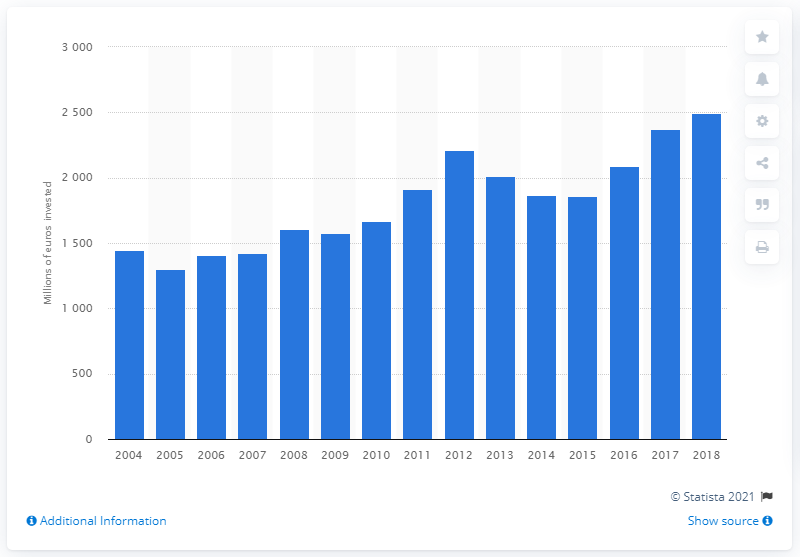Specify some key components in this picture. In 2018, investments in road transport infrastructure in Sweden exceeded 2497. In 2005, the amount of road transport infrastructure investments in Sweden was 1,297.94. 